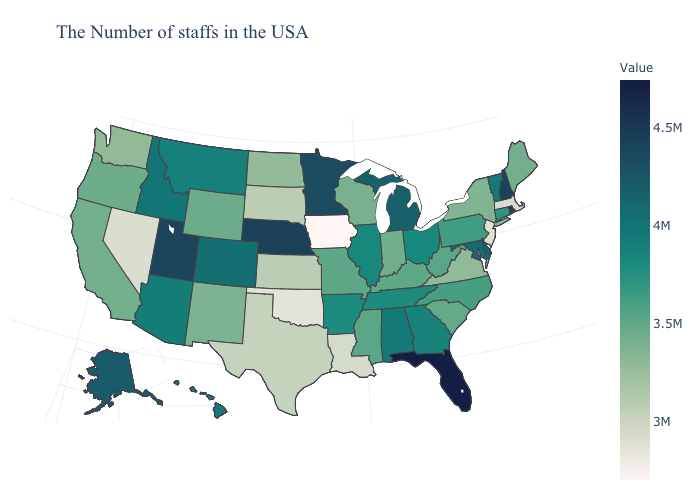Which states have the lowest value in the USA?
Write a very short answer. Iowa. Does Rhode Island have a lower value than Florida?
Keep it brief. Yes. Among the states that border Virginia , does Maryland have the highest value?
Keep it brief. Yes. Among the states that border Arizona , which have the lowest value?
Keep it brief. Nevada. Does Iowa have the lowest value in the USA?
Keep it brief. Yes. Which states have the lowest value in the Northeast?
Give a very brief answer. New Jersey. Does New Jersey have a higher value than California?
Be succinct. No. 